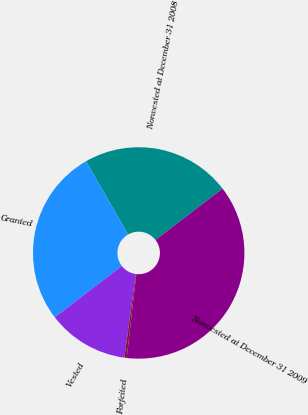<chart> <loc_0><loc_0><loc_500><loc_500><pie_chart><fcel>Nonvested at December 31 2008<fcel>Granted<fcel>Vested<fcel>Forfeited<fcel>Nonvested at December 31 2009<nl><fcel>22.89%<fcel>27.11%<fcel>12.43%<fcel>0.35%<fcel>37.22%<nl></chart> 